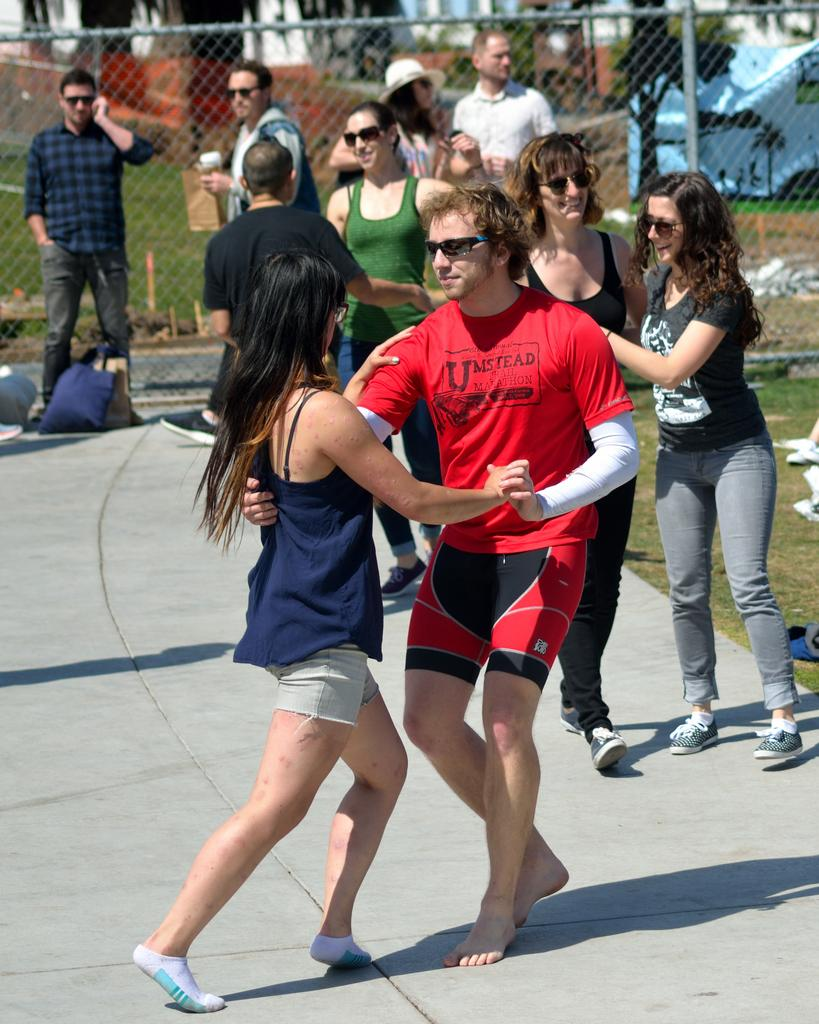What is the main subject of the image? The main subject of the image is a group of people. What are the people in the image wearing? The people in the image are wearing clothes. What is in the background of the image? There is a fencing in the background of the image. How many persons are in the middle of the image? There are two persons in the middle of the image. What are the two persons in the middle of the image doing? The two persons in the middle of the image are dancing on the floor. What type of hat is the fifth person wearing in the image? There is no fifth person present in the image, and therefore no hat to describe. 